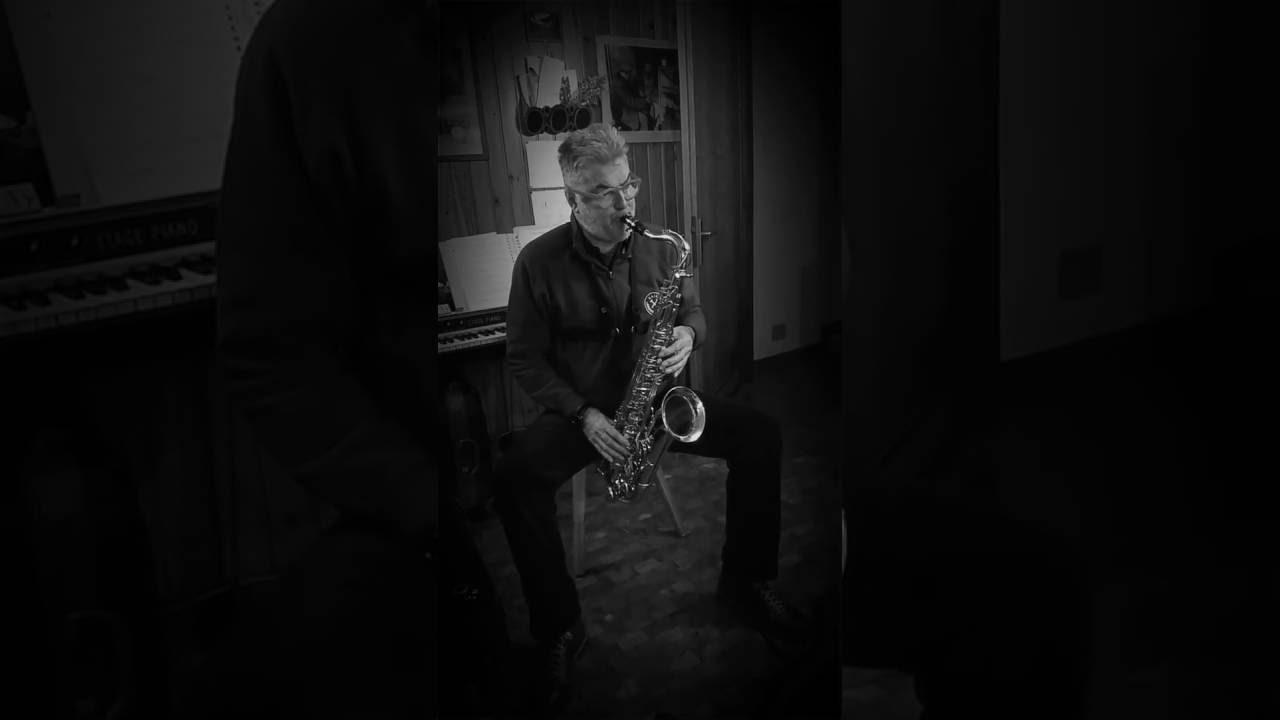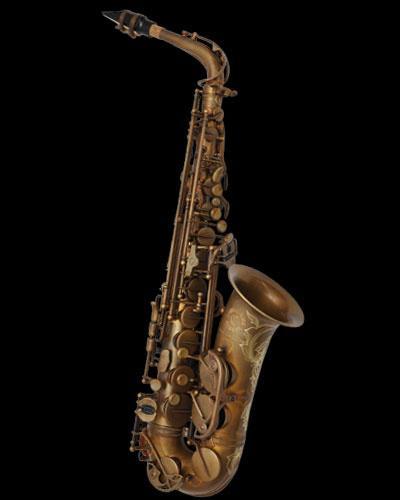The first image is the image on the left, the second image is the image on the right. Considering the images on both sides, is "The left image shows one saxophone displayed upright with its bell facing right, and the right image shows decorative etching embellishing the bell-end of a saxophone." valid? Answer yes or no. No. The first image is the image on the left, the second image is the image on the right. Assess this claim about the two images: "The mouthpiece is visible in both images.". Correct or not? Answer yes or no. Yes. 